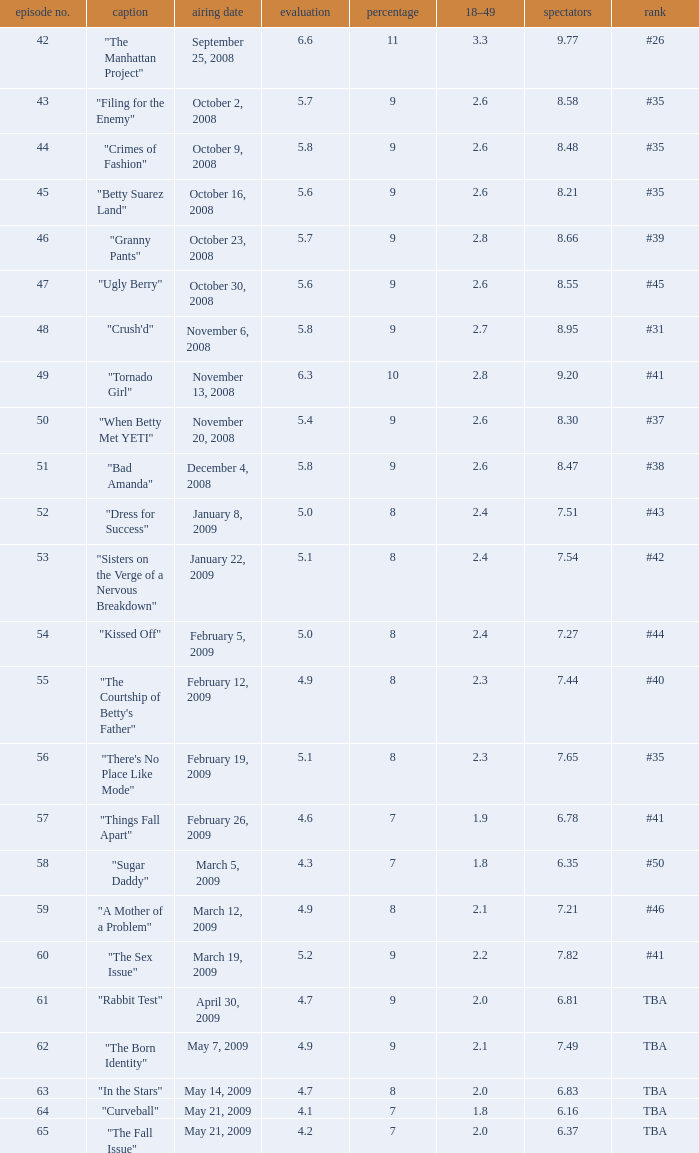What is the total number of Viewers when the rank is #40? 1.0. 